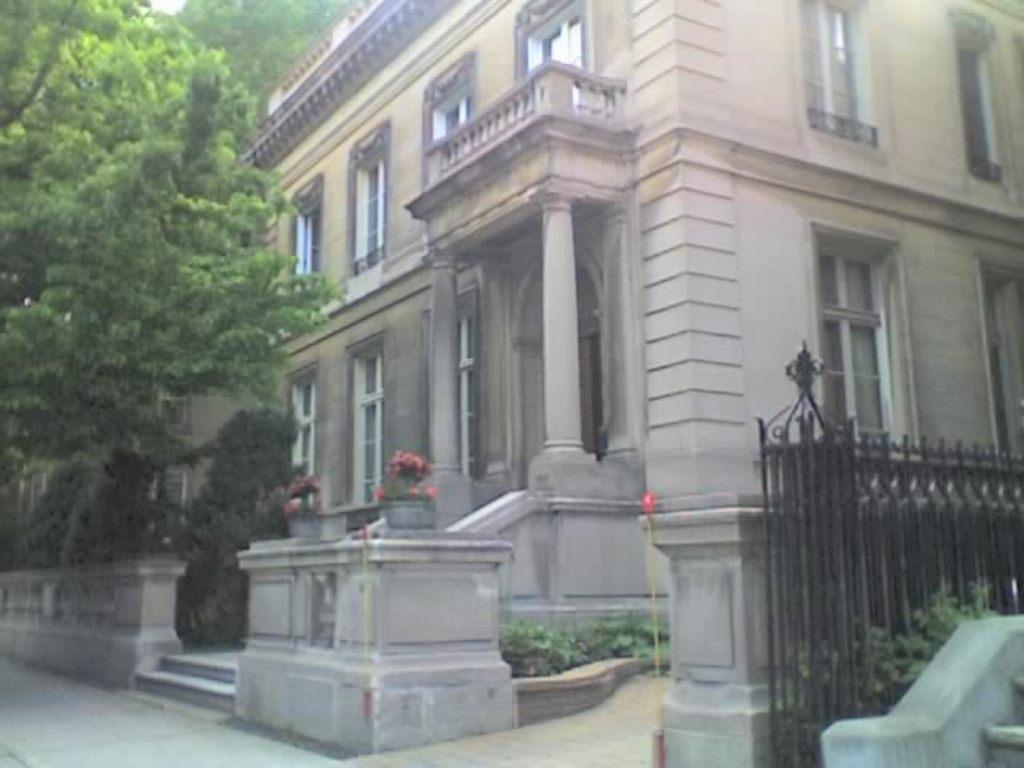What type of structure is visible in the image? There is a building in the image. What can be seen on the left side of the image? There are trees on the left side of the image. What type of door can be seen on the building in the image? There is no door visible on the building in the image. What type of metal is used to construct the trees in the image? The trees in the image are not made of metal; they are natural vegetation. 